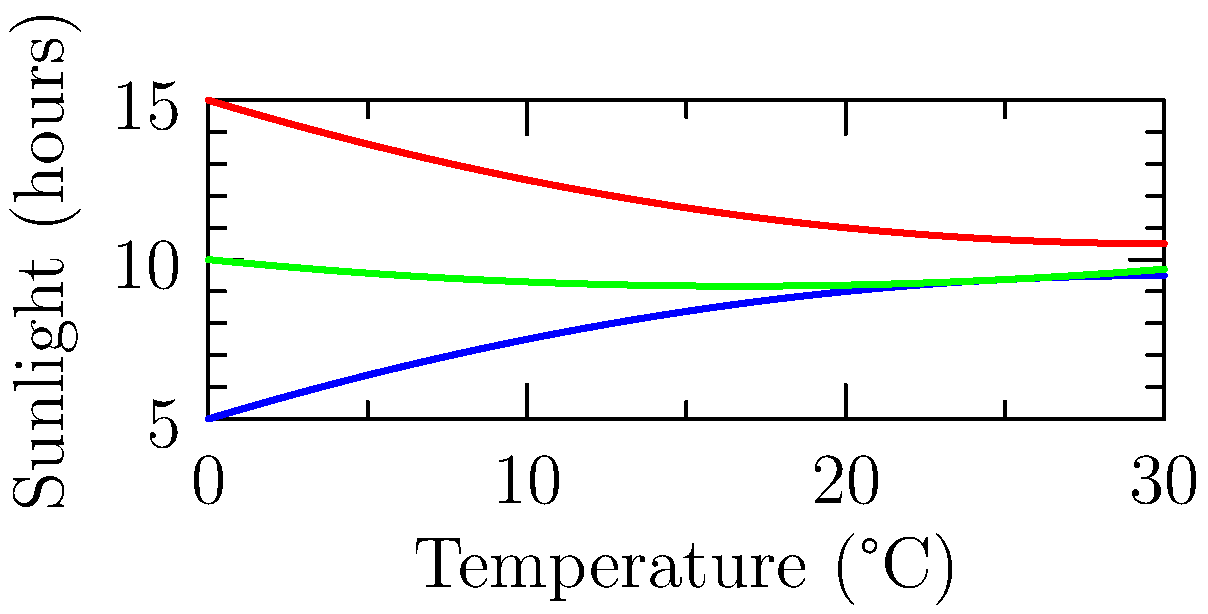Based on the graph showing the relationship between temperature, sunlight, and growth for sage, basil, and rosemary, which herb requires the most sunlight at its optimal temperature? To determine which herb requires the most sunlight at its optimal temperature, we need to follow these steps:

1. Identify the optimal temperature for each herb by finding the peak of each curve:
   - Sage (red): Peak at approximately 30°C
   - Basil (blue): Peak at approximately 30°C
   - Rosemary (green): Peak at approximately 16-17°C

2. Compare the sunlight hours required at these optimal temperatures:
   - Sage at 30°C: About 10 hours of sunlight
   - Basil at 30°C: About 14 hours of sunlight
   - Rosemary at 16-17°C: About 12 hours of sunlight

3. Identify the herb with the highest sunlight requirement at its optimal temperature:
   Basil requires the most sunlight (approximately 14 hours) at its optimal temperature of 30°C.

Therefore, basil is the herb that requires the most sunlight at its optimal temperature.
Answer: Basil 